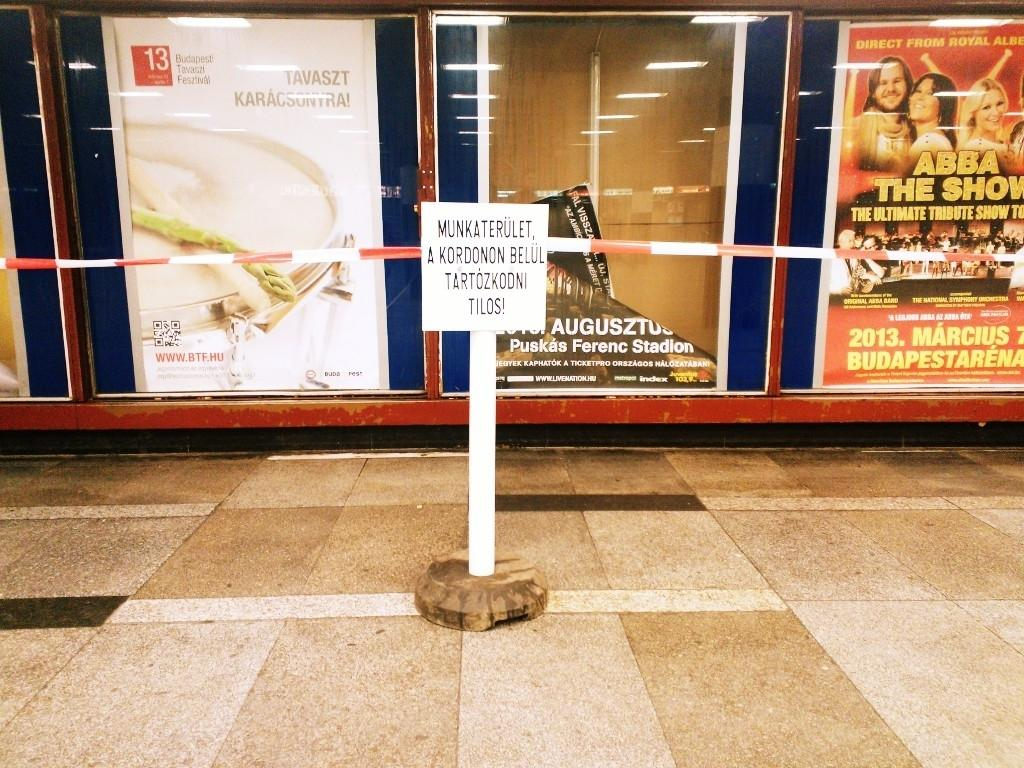<image>
Create a compact narrative representing the image presented. Many advertisements are on the wall, one of which is for ABBA The Show. 